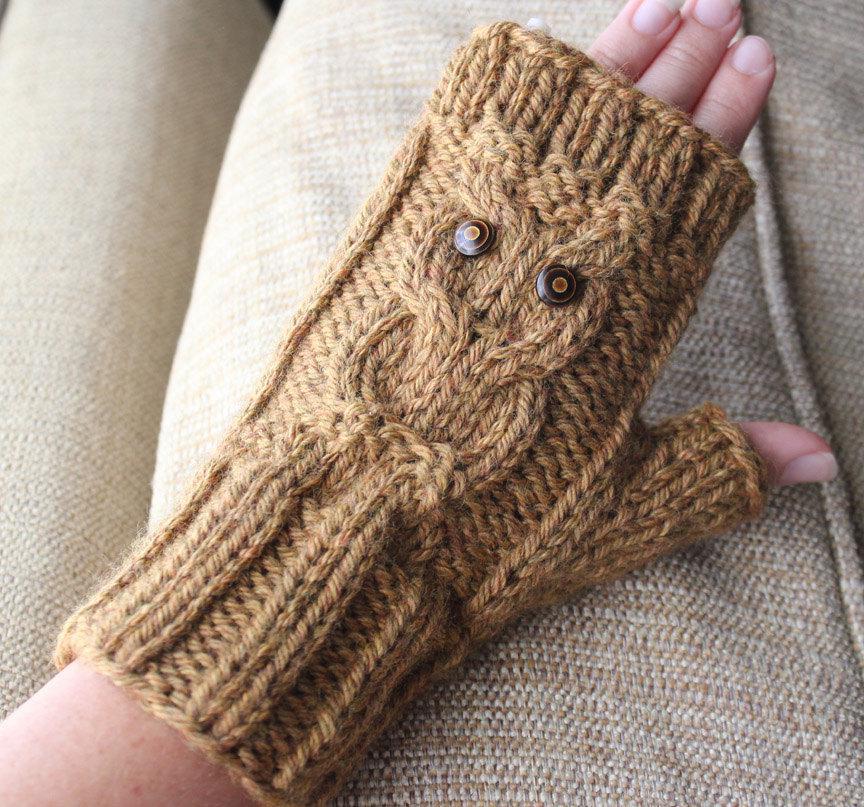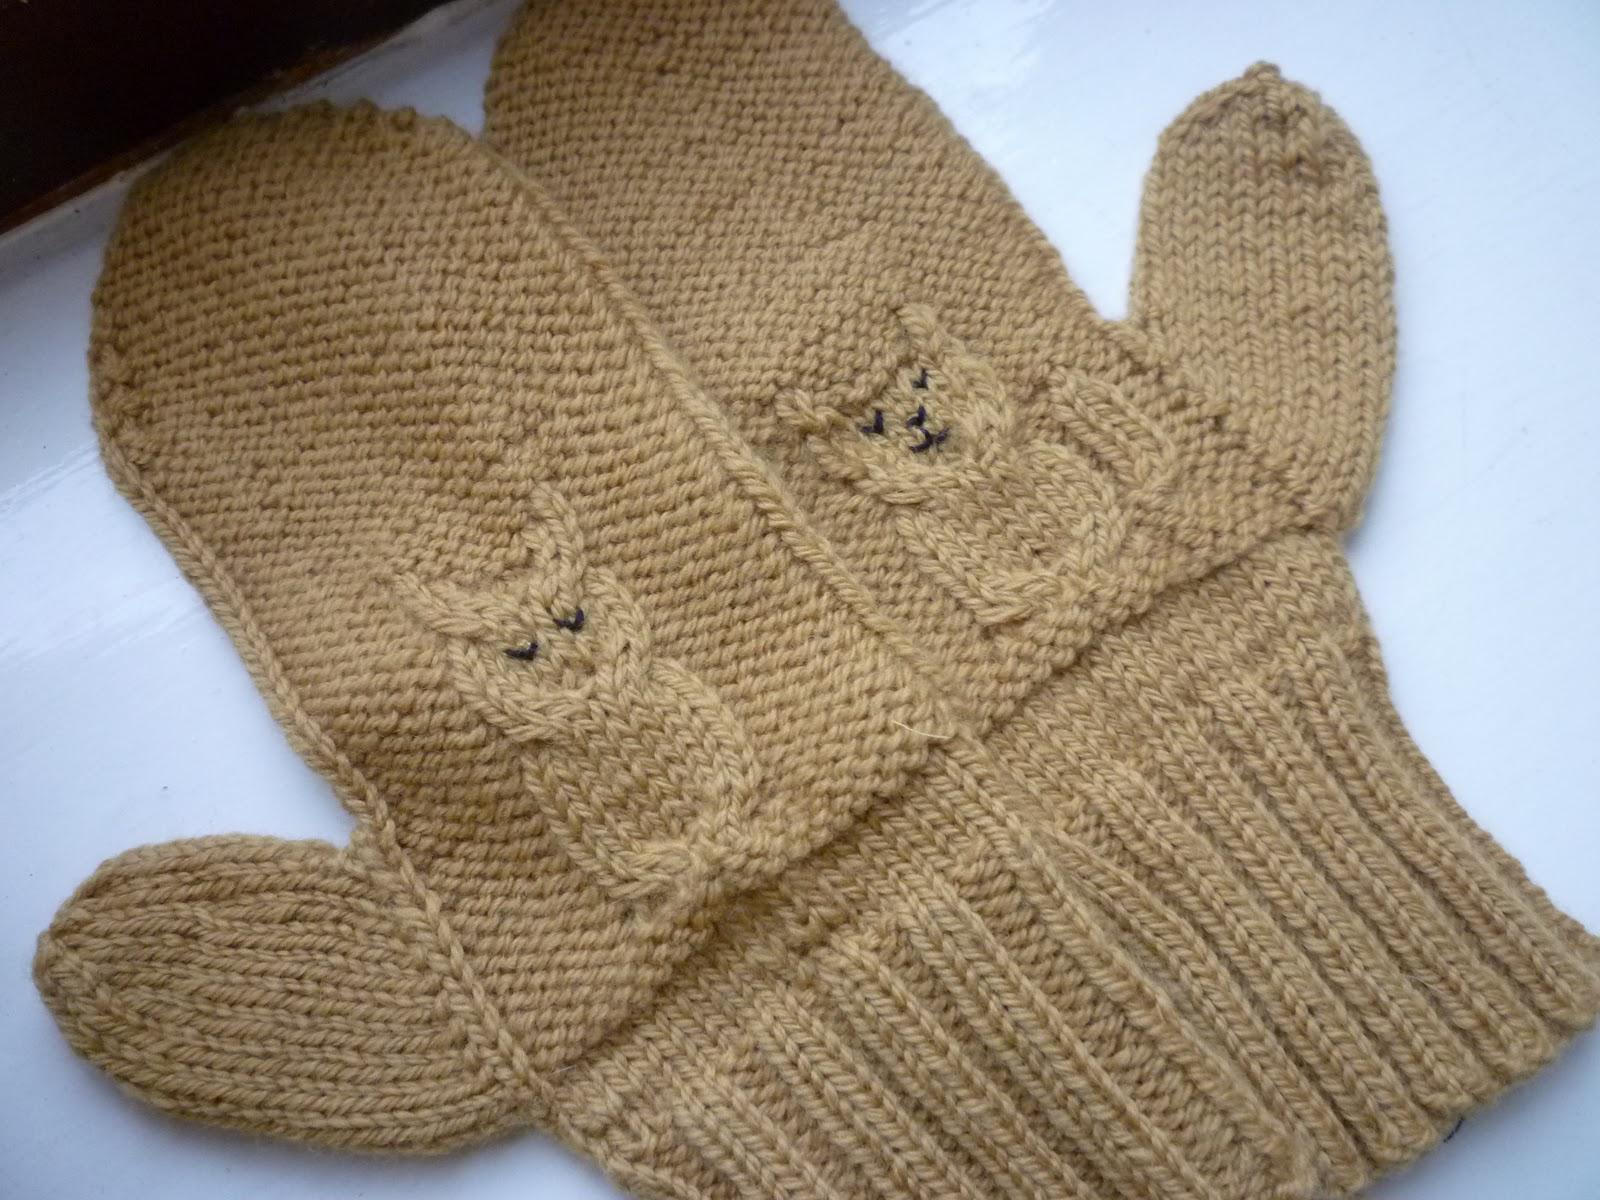The first image is the image on the left, the second image is the image on the right. Evaluate the accuracy of this statement regarding the images: "The right image is of two hands wearing turquoise fingerless mittens.". Is it true? Answer yes or no. No. The first image is the image on the left, the second image is the image on the right. Evaluate the accuracy of this statement regarding the images: "Four hands have gloves on them.". Is it true? Answer yes or no. No. 